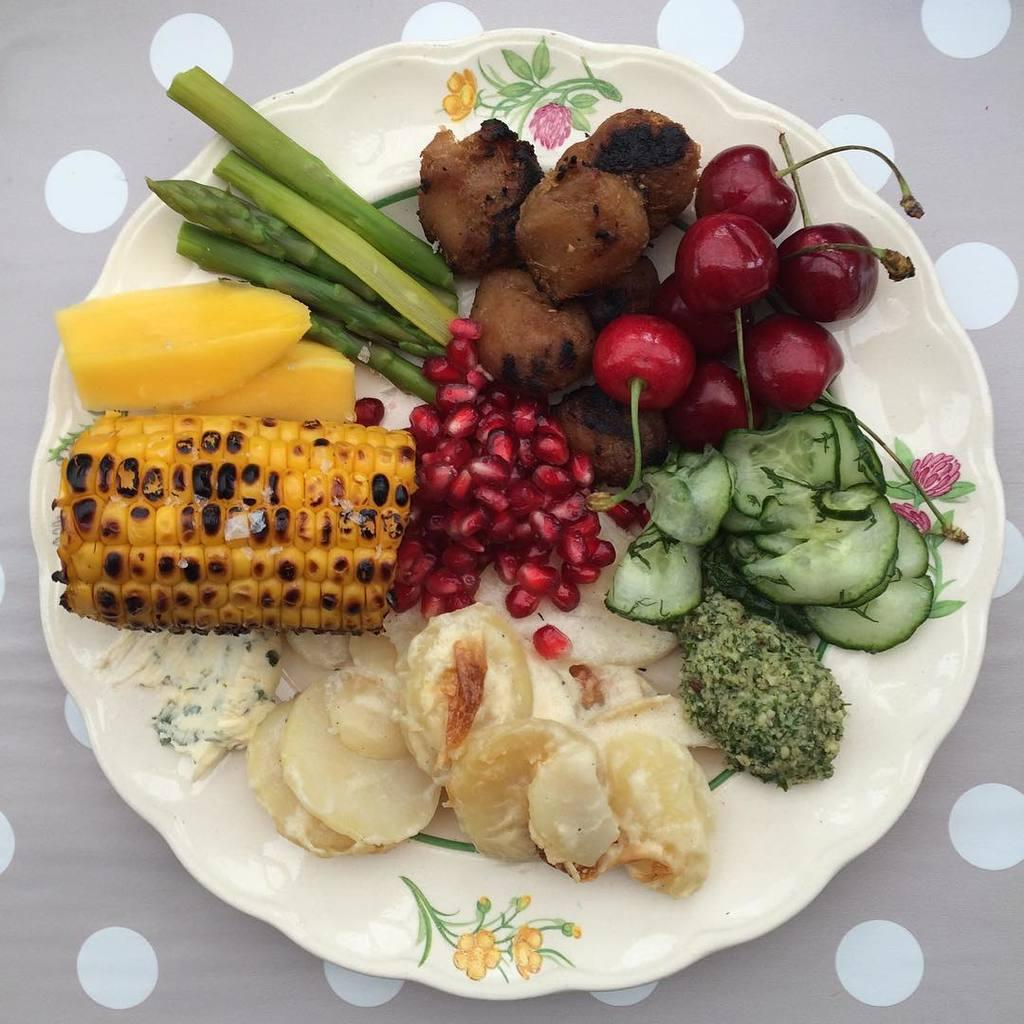What types of food can be seen on the plates in the image? There are fruits and vegetables on the plates in the image. Where are the plates with food located? The plates are placed on a table. What types of pets can be seen in the image? There are no pets visible in the image. What does the image smell like? It is not possible to determine the smell of the image through a visual representation. 